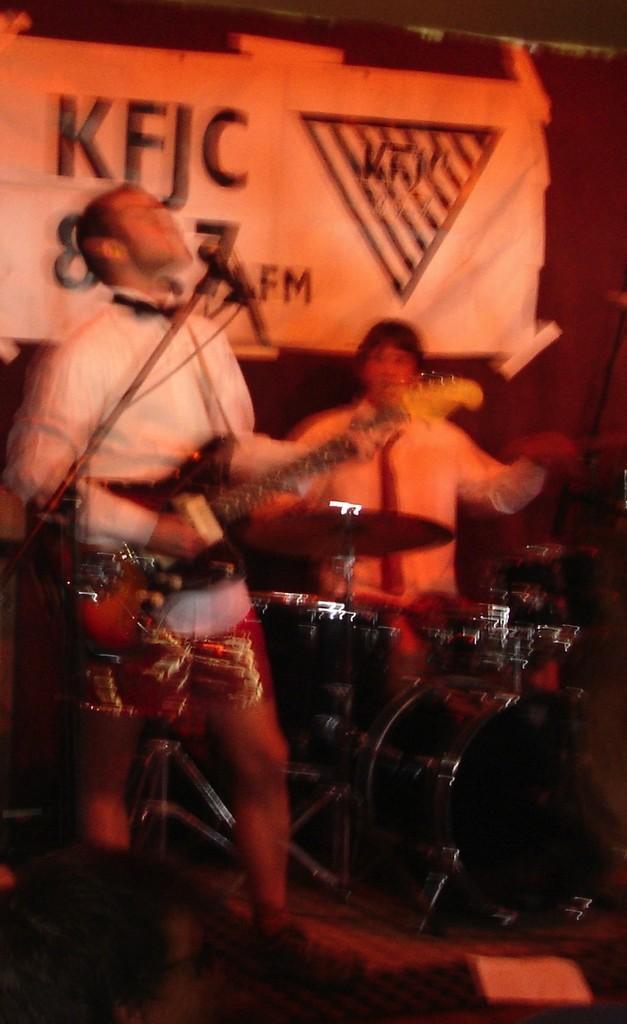Can you describe this image briefly? In this image I see 2 persons in which one of them is holding a guitar and he is in front of a mic and there are drums over here. In the background I see the banner. 